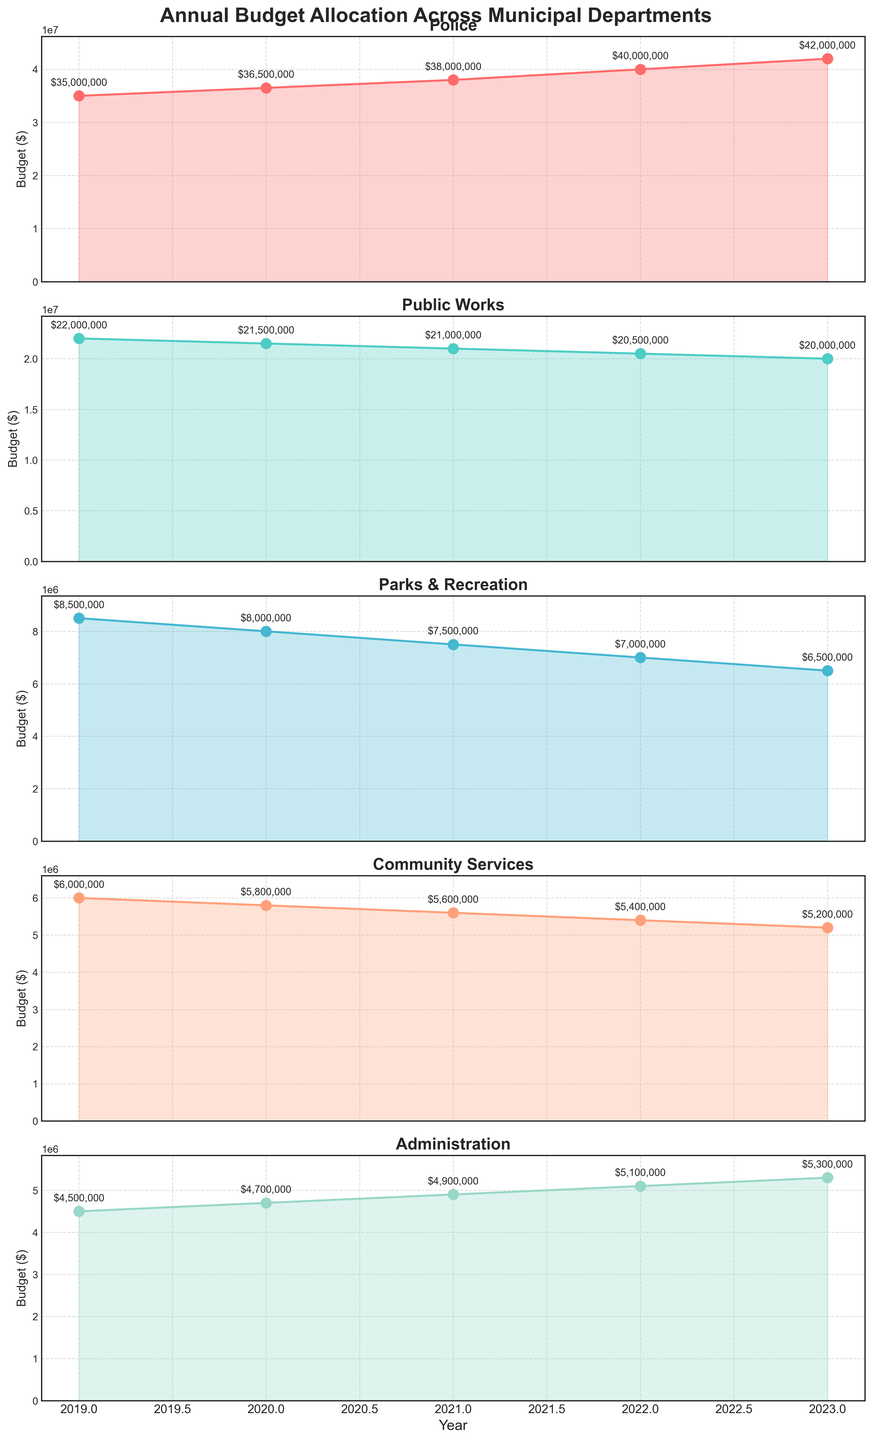what is the average budget allocated to the Police department over the last 5 years? To calculate the average, sum up the police budget for each year and divide by the number of years. Sum: 35000000 + 36500000 + 38000000 + 40000000 + 42000000 = 191500000. Divide by 5: 191500000 / 5 = 38300000
Answer: 38300000 Which department experienced the largest absolute decrease in budget from 2019 to 2023? To find the largest absolute decrease, we subtract the 2023 values from the 2019 values for each department and compare the differences: 
- Public Works: 22000000 - 20000000 = 2000000
- Parks & Recreation: 8500000 - 6500000 = 2000000
- Community Services: 6000000 - 5200000 = 800000
- Administration: 4500000 - 5300000 = -800000. Public Works and Parks & Recreation tie for the largest decrease.
Answer: Public Works, Parks & Rec Does any department’s budget show an increasing trend every consecutive year from 2019 to 2023? An increasing trend means each year's budget must be higher than the previous year. By examining the plot:
- Police: 35000000 → 36500000 → 38000000 → 40000000 → 42000000 (increasing trend)
No other department has an unbroken increasing trend.
Answer: Police What's the total budget allocated to Community Services over the last 5 years? To calculate the total budget, sum up the Community Services budget for each year: 6000000 (2019) + 5800000 (2020) + 5600000 (2021) + 5400000 (2022) + 5200000 (2023) = 28000000
Answer: 28000000 How does the budget variation for Public Works compare to the variation for Administration over the last 5 years? Calculate the range (max - min) for both departments: 
- Public Works: max (22000000) - min (20000000) = 2000000
- Administration: max (5300000) - min (4500000) = 800000. Public Works has a higher variation than Administration.
Answer: Public Works > Administration Which year saw the smallest budget for Parks & Recreation? By looking at the plot's line for Parks & Recreation, 2023 shows the smallest budget: 6500000 (2023 is lower than other years).
Answer: 2023 In what year was the Police budget 10% more than the Parks & Recreation budget for that same year? Calculate 110% of the Parks & Recreation budget for each year and compare it to the Police budget:
- 2019: 110% of 8500000 = 9350000 (not equal to 35000000)
- 2020: 110% of 8000000 = 8800000 (not equal to 36500000)
- 2021: 110% of 7500000 = 8250000 (not equal to 38000000)
- 2022: 110% of 7000000 = 7700000 (not equal to 40000000)
- 2023: 110% of 6500000 = 7150000 (not equal to 42000000). 
No year meets the condition.
Answer: None 